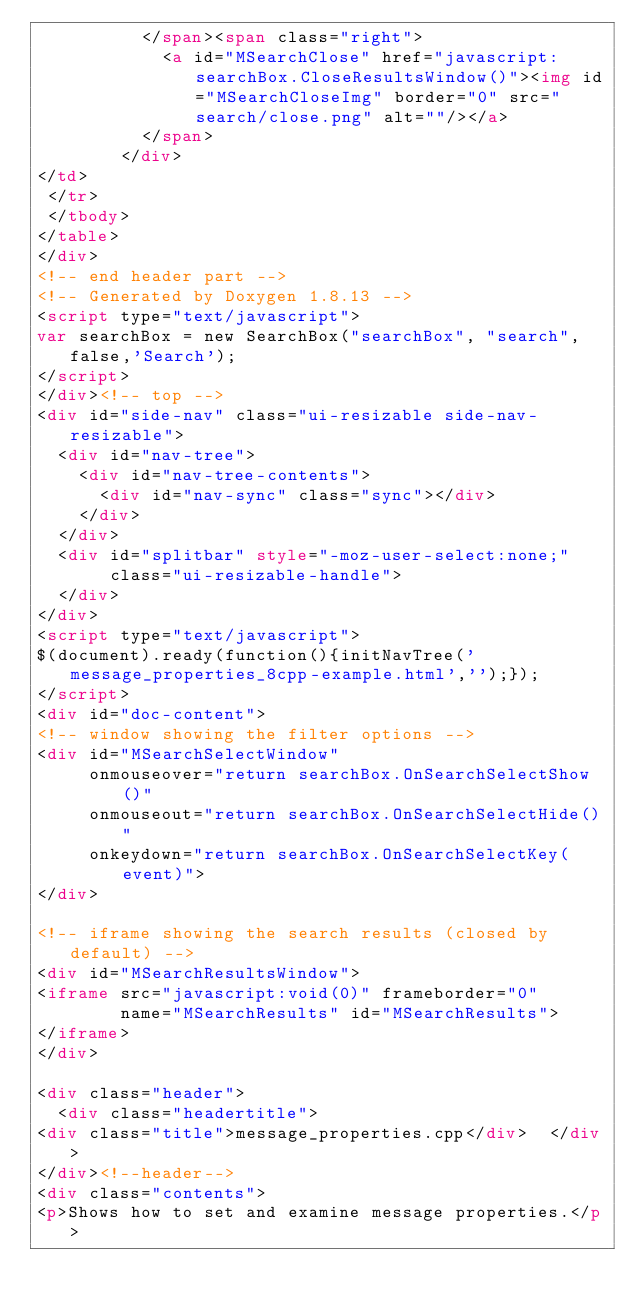<code> <loc_0><loc_0><loc_500><loc_500><_HTML_>          </span><span class="right">
            <a id="MSearchClose" href="javascript:searchBox.CloseResultsWindow()"><img id="MSearchCloseImg" border="0" src="search/close.png" alt=""/></a>
          </span>
        </div>
</td>
 </tr>
 </tbody>
</table>
</div>
<!-- end header part -->
<!-- Generated by Doxygen 1.8.13 -->
<script type="text/javascript">
var searchBox = new SearchBox("searchBox", "search",false,'Search');
</script>
</div><!-- top -->
<div id="side-nav" class="ui-resizable side-nav-resizable">
  <div id="nav-tree">
    <div id="nav-tree-contents">
      <div id="nav-sync" class="sync"></div>
    </div>
  </div>
  <div id="splitbar" style="-moz-user-select:none;" 
       class="ui-resizable-handle">
  </div>
</div>
<script type="text/javascript">
$(document).ready(function(){initNavTree('message_properties_8cpp-example.html','');});
</script>
<div id="doc-content">
<!-- window showing the filter options -->
<div id="MSearchSelectWindow"
     onmouseover="return searchBox.OnSearchSelectShow()"
     onmouseout="return searchBox.OnSearchSelectHide()"
     onkeydown="return searchBox.OnSearchSelectKey(event)">
</div>

<!-- iframe showing the search results (closed by default) -->
<div id="MSearchResultsWindow">
<iframe src="javascript:void(0)" frameborder="0" 
        name="MSearchResults" id="MSearchResults">
</iframe>
</div>

<div class="header">
  <div class="headertitle">
<div class="title">message_properties.cpp</div>  </div>
</div><!--header-->
<div class="contents">
<p>Shows how to set and examine message properties.</p></code> 